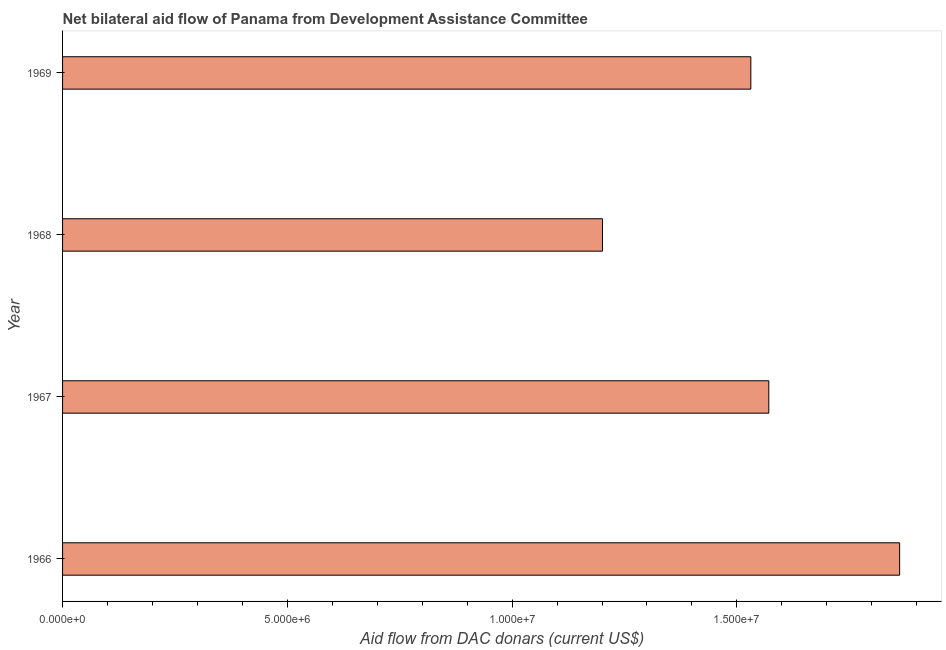What is the title of the graph?
Make the answer very short. Net bilateral aid flow of Panama from Development Assistance Committee. What is the label or title of the X-axis?
Offer a very short reply. Aid flow from DAC donars (current US$). What is the net bilateral aid flows from dac donors in 1967?
Your answer should be compact. 1.57e+07. Across all years, what is the maximum net bilateral aid flows from dac donors?
Offer a very short reply. 1.86e+07. Across all years, what is the minimum net bilateral aid flows from dac donors?
Offer a terse response. 1.20e+07. In which year was the net bilateral aid flows from dac donors maximum?
Your response must be concise. 1966. In which year was the net bilateral aid flows from dac donors minimum?
Make the answer very short. 1968. What is the sum of the net bilateral aid flows from dac donors?
Offer a very short reply. 6.16e+07. What is the difference between the net bilateral aid flows from dac donors in 1967 and 1968?
Your response must be concise. 3.70e+06. What is the average net bilateral aid flows from dac donors per year?
Your response must be concise. 1.54e+07. What is the median net bilateral aid flows from dac donors?
Give a very brief answer. 1.55e+07. What is the ratio of the net bilateral aid flows from dac donors in 1967 to that in 1968?
Your response must be concise. 1.31. Is the net bilateral aid flows from dac donors in 1968 less than that in 1969?
Offer a very short reply. Yes. Is the difference between the net bilateral aid flows from dac donors in 1967 and 1968 greater than the difference between any two years?
Provide a short and direct response. No. What is the difference between the highest and the second highest net bilateral aid flows from dac donors?
Keep it short and to the point. 2.91e+06. Is the sum of the net bilateral aid flows from dac donors in 1966 and 1968 greater than the maximum net bilateral aid flows from dac donors across all years?
Make the answer very short. Yes. What is the difference between the highest and the lowest net bilateral aid flows from dac donors?
Your response must be concise. 6.61e+06. In how many years, is the net bilateral aid flows from dac donors greater than the average net bilateral aid flows from dac donors taken over all years?
Provide a succinct answer. 2. Are all the bars in the graph horizontal?
Provide a short and direct response. Yes. Are the values on the major ticks of X-axis written in scientific E-notation?
Your answer should be compact. Yes. What is the Aid flow from DAC donars (current US$) of 1966?
Provide a short and direct response. 1.86e+07. What is the Aid flow from DAC donars (current US$) in 1967?
Give a very brief answer. 1.57e+07. What is the Aid flow from DAC donars (current US$) of 1968?
Offer a very short reply. 1.20e+07. What is the Aid flow from DAC donars (current US$) in 1969?
Ensure brevity in your answer.  1.53e+07. What is the difference between the Aid flow from DAC donars (current US$) in 1966 and 1967?
Keep it short and to the point. 2.91e+06. What is the difference between the Aid flow from DAC donars (current US$) in 1966 and 1968?
Your answer should be very brief. 6.61e+06. What is the difference between the Aid flow from DAC donars (current US$) in 1966 and 1969?
Your answer should be very brief. 3.31e+06. What is the difference between the Aid flow from DAC donars (current US$) in 1967 and 1968?
Give a very brief answer. 3.70e+06. What is the difference between the Aid flow from DAC donars (current US$) in 1968 and 1969?
Give a very brief answer. -3.30e+06. What is the ratio of the Aid flow from DAC donars (current US$) in 1966 to that in 1967?
Provide a short and direct response. 1.19. What is the ratio of the Aid flow from DAC donars (current US$) in 1966 to that in 1968?
Your answer should be very brief. 1.55. What is the ratio of the Aid flow from DAC donars (current US$) in 1966 to that in 1969?
Make the answer very short. 1.22. What is the ratio of the Aid flow from DAC donars (current US$) in 1967 to that in 1968?
Provide a short and direct response. 1.31. What is the ratio of the Aid flow from DAC donars (current US$) in 1967 to that in 1969?
Your response must be concise. 1.03. What is the ratio of the Aid flow from DAC donars (current US$) in 1968 to that in 1969?
Your response must be concise. 0.78. 